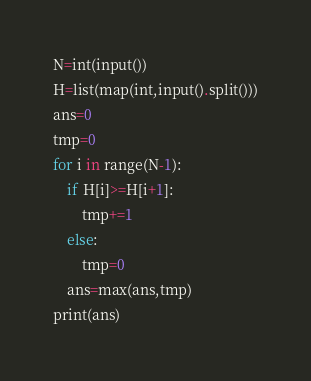<code> <loc_0><loc_0><loc_500><loc_500><_Python_>N=int(input())
H=list(map(int,input().split()))
ans=0
tmp=0
for i in range(N-1):
    if H[i]>=H[i+1]:
        tmp+=1
    else:
        tmp=0
    ans=max(ans,tmp)
print(ans)</code> 